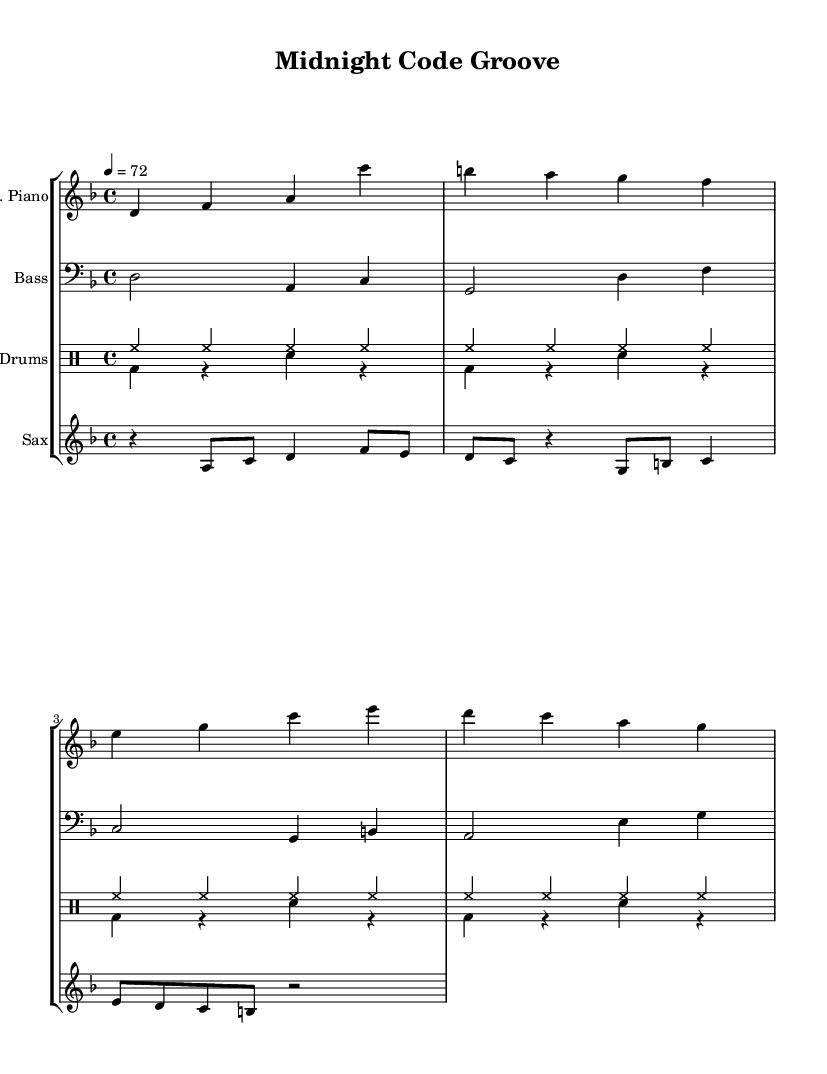What is the key signature of this music? The key signature is listed at the beginning of the global section and is indicated as D minor, which contains one flat.
Answer: D minor What is the time signature of this music? The time signature is found in the global section, indicated by "4/4", meaning there are four beats in each measure.
Answer: 4/4 What is the tempo marking? The tempo marking is specified in the global section as "4 = 72", indicating that there are 72 quarter notes per minute.
Answer: 72 How many measures are there in the electric piano part? To determine this, we can count the number of measure bars in the electricPiano segment. The total is four measures in that section.
Answer: 4 What is the total number of different instruments indicated in the score? The score includes a staff for electric piano, bass, drums, and saxophone, totaling four different instruments.
Answer: 4 Which instrument plays in the treble clef? The instrument indicated in treble clef is the electric piano, as specified in its staff grouping.
Answer: Electric Piano What rhythmic element is emphasized in the drum pattern? The hi-hat is consistently played in every measure of the drum pattern, providing a steady rhythmic pulse throughout the piece.
Answer: Hi-hat 